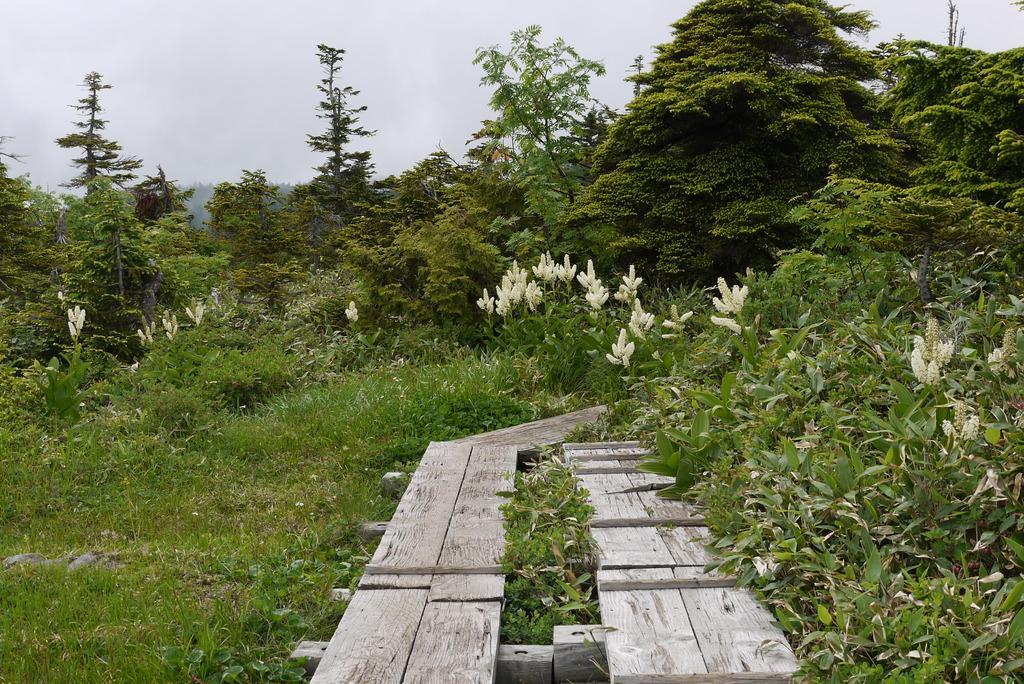How would you summarize this image in a sentence or two? This picture might be taken from outside of the city. In this image, we can see a wood bridge. On the right side, we can see some trees and plants with some flowers. On the left side, we can also see some trees and plants with some flowers. In the background, we can also see some trees. On the top, we can see a sky. 